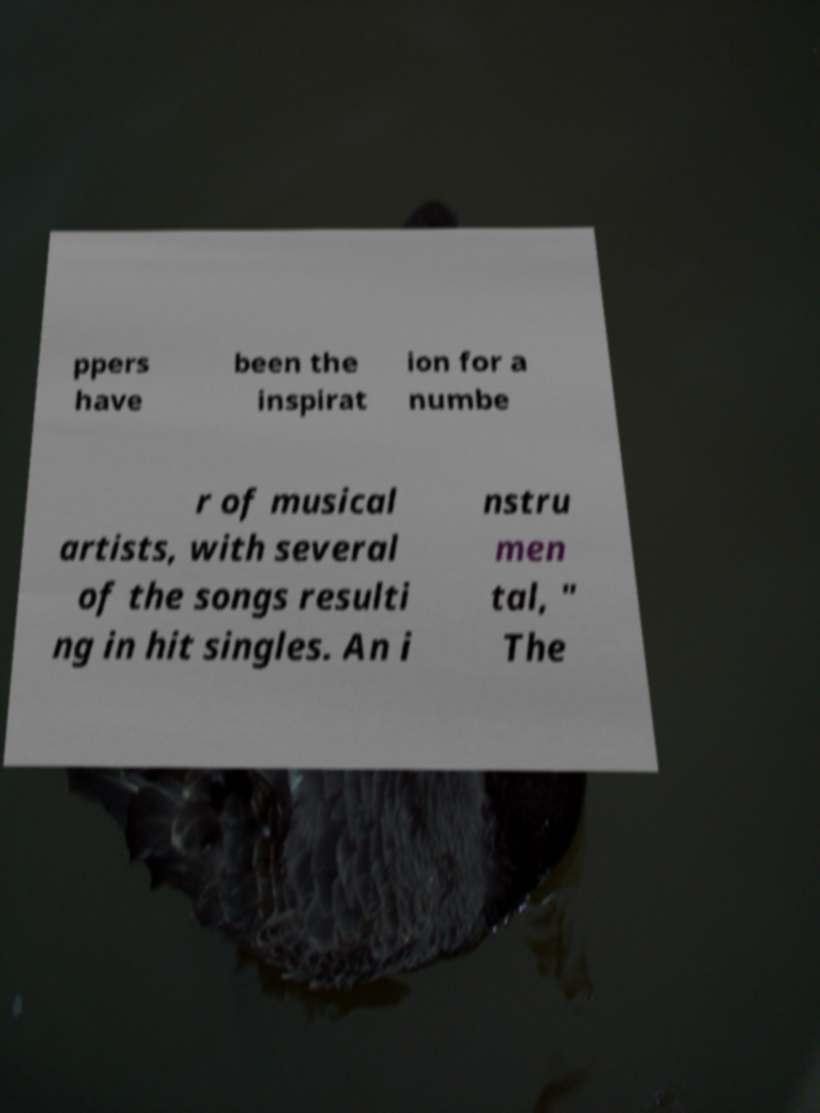There's text embedded in this image that I need extracted. Can you transcribe it verbatim? ppers have been the inspirat ion for a numbe r of musical artists, with several of the songs resulti ng in hit singles. An i nstru men tal, " The 